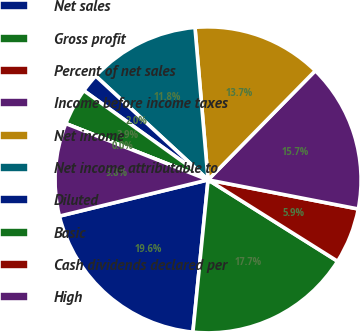Convert chart. <chart><loc_0><loc_0><loc_500><loc_500><pie_chart><fcel>Net sales<fcel>Gross profit<fcel>Percent of net sales<fcel>Income before income taxes<fcel>Net income<fcel>Net income attributable to<fcel>Diluted<fcel>Basic<fcel>Cash dividends declared per<fcel>High<nl><fcel>19.61%<fcel>17.65%<fcel>5.88%<fcel>15.69%<fcel>13.72%<fcel>11.76%<fcel>1.96%<fcel>3.92%<fcel>0.0%<fcel>9.8%<nl></chart> 